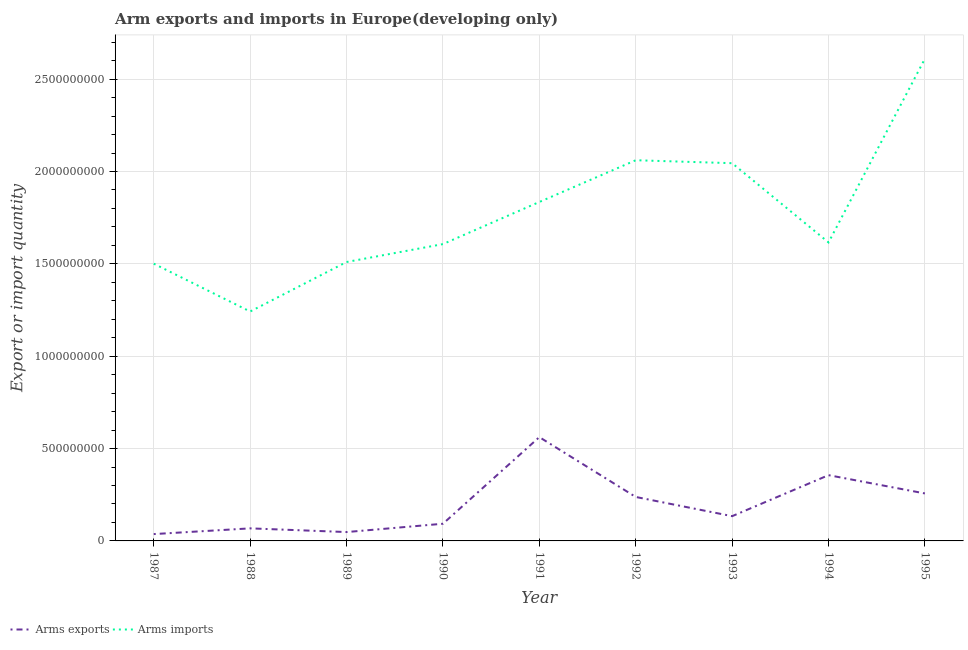Does the line corresponding to arms imports intersect with the line corresponding to arms exports?
Offer a terse response. No. What is the arms imports in 1987?
Your answer should be very brief. 1.50e+09. Across all years, what is the maximum arms exports?
Give a very brief answer. 5.62e+08. Across all years, what is the minimum arms exports?
Offer a very short reply. 3.70e+07. In which year was the arms imports maximum?
Offer a very short reply. 1995. What is the total arms imports in the graph?
Your response must be concise. 1.60e+1. What is the difference between the arms imports in 1990 and that in 1992?
Your answer should be very brief. -4.54e+08. What is the difference between the arms imports in 1990 and the arms exports in 1995?
Provide a short and direct response. 1.35e+09. What is the average arms exports per year?
Ensure brevity in your answer.  1.99e+08. In the year 1995, what is the difference between the arms exports and arms imports?
Your answer should be compact. -2.35e+09. In how many years, is the arms exports greater than 2400000000?
Provide a short and direct response. 0. What is the ratio of the arms imports in 1988 to that in 1989?
Offer a very short reply. 0.82. What is the difference between the highest and the second highest arms exports?
Your answer should be compact. 2.06e+08. What is the difference between the highest and the lowest arms exports?
Offer a terse response. 5.25e+08. Is the arms imports strictly greater than the arms exports over the years?
Provide a succinct answer. Yes. How many lines are there?
Make the answer very short. 2. What is the difference between two consecutive major ticks on the Y-axis?
Make the answer very short. 5.00e+08. Are the values on the major ticks of Y-axis written in scientific E-notation?
Your answer should be very brief. No. Does the graph contain any zero values?
Your answer should be very brief. No. Where does the legend appear in the graph?
Offer a terse response. Bottom left. How many legend labels are there?
Provide a succinct answer. 2. What is the title of the graph?
Offer a terse response. Arm exports and imports in Europe(developing only). Does "DAC donors" appear as one of the legend labels in the graph?
Offer a very short reply. No. What is the label or title of the Y-axis?
Ensure brevity in your answer.  Export or import quantity. What is the Export or import quantity in Arms exports in 1987?
Provide a short and direct response. 3.70e+07. What is the Export or import quantity in Arms imports in 1987?
Your answer should be very brief. 1.50e+09. What is the Export or import quantity in Arms exports in 1988?
Your answer should be compact. 6.80e+07. What is the Export or import quantity in Arms imports in 1988?
Your answer should be very brief. 1.24e+09. What is the Export or import quantity of Arms exports in 1989?
Offer a very short reply. 4.80e+07. What is the Export or import quantity of Arms imports in 1989?
Offer a terse response. 1.51e+09. What is the Export or import quantity in Arms exports in 1990?
Ensure brevity in your answer.  9.30e+07. What is the Export or import quantity of Arms imports in 1990?
Provide a short and direct response. 1.61e+09. What is the Export or import quantity of Arms exports in 1991?
Provide a succinct answer. 5.62e+08. What is the Export or import quantity in Arms imports in 1991?
Provide a short and direct response. 1.84e+09. What is the Export or import quantity in Arms exports in 1992?
Your answer should be compact. 2.38e+08. What is the Export or import quantity in Arms imports in 1992?
Ensure brevity in your answer.  2.06e+09. What is the Export or import quantity in Arms exports in 1993?
Provide a succinct answer. 1.34e+08. What is the Export or import quantity of Arms imports in 1993?
Offer a terse response. 2.04e+09. What is the Export or import quantity in Arms exports in 1994?
Ensure brevity in your answer.  3.56e+08. What is the Export or import quantity in Arms imports in 1994?
Give a very brief answer. 1.62e+09. What is the Export or import quantity of Arms exports in 1995?
Ensure brevity in your answer.  2.57e+08. What is the Export or import quantity in Arms imports in 1995?
Your response must be concise. 2.61e+09. Across all years, what is the maximum Export or import quantity of Arms exports?
Keep it short and to the point. 5.62e+08. Across all years, what is the maximum Export or import quantity of Arms imports?
Your response must be concise. 2.61e+09. Across all years, what is the minimum Export or import quantity of Arms exports?
Ensure brevity in your answer.  3.70e+07. Across all years, what is the minimum Export or import quantity of Arms imports?
Offer a very short reply. 1.24e+09. What is the total Export or import quantity of Arms exports in the graph?
Provide a short and direct response. 1.79e+09. What is the total Export or import quantity in Arms imports in the graph?
Keep it short and to the point. 1.60e+1. What is the difference between the Export or import quantity in Arms exports in 1987 and that in 1988?
Give a very brief answer. -3.10e+07. What is the difference between the Export or import quantity of Arms imports in 1987 and that in 1988?
Provide a short and direct response. 2.59e+08. What is the difference between the Export or import quantity in Arms exports in 1987 and that in 1989?
Provide a short and direct response. -1.10e+07. What is the difference between the Export or import quantity in Arms imports in 1987 and that in 1989?
Your response must be concise. -9.00e+06. What is the difference between the Export or import quantity in Arms exports in 1987 and that in 1990?
Keep it short and to the point. -5.60e+07. What is the difference between the Export or import quantity in Arms imports in 1987 and that in 1990?
Your answer should be compact. -1.06e+08. What is the difference between the Export or import quantity of Arms exports in 1987 and that in 1991?
Your answer should be very brief. -5.25e+08. What is the difference between the Export or import quantity of Arms imports in 1987 and that in 1991?
Your answer should be very brief. -3.34e+08. What is the difference between the Export or import quantity in Arms exports in 1987 and that in 1992?
Your response must be concise. -2.01e+08. What is the difference between the Export or import quantity of Arms imports in 1987 and that in 1992?
Provide a short and direct response. -5.60e+08. What is the difference between the Export or import quantity of Arms exports in 1987 and that in 1993?
Offer a very short reply. -9.70e+07. What is the difference between the Export or import quantity in Arms imports in 1987 and that in 1993?
Offer a very short reply. -5.44e+08. What is the difference between the Export or import quantity in Arms exports in 1987 and that in 1994?
Provide a short and direct response. -3.19e+08. What is the difference between the Export or import quantity of Arms imports in 1987 and that in 1994?
Make the answer very short. -1.15e+08. What is the difference between the Export or import quantity of Arms exports in 1987 and that in 1995?
Make the answer very short. -2.20e+08. What is the difference between the Export or import quantity in Arms imports in 1987 and that in 1995?
Your response must be concise. -1.11e+09. What is the difference between the Export or import quantity in Arms exports in 1988 and that in 1989?
Offer a terse response. 2.00e+07. What is the difference between the Export or import quantity of Arms imports in 1988 and that in 1989?
Provide a succinct answer. -2.68e+08. What is the difference between the Export or import quantity of Arms exports in 1988 and that in 1990?
Your answer should be very brief. -2.50e+07. What is the difference between the Export or import quantity in Arms imports in 1988 and that in 1990?
Give a very brief answer. -3.65e+08. What is the difference between the Export or import quantity in Arms exports in 1988 and that in 1991?
Offer a very short reply. -4.94e+08. What is the difference between the Export or import quantity of Arms imports in 1988 and that in 1991?
Offer a terse response. -5.93e+08. What is the difference between the Export or import quantity of Arms exports in 1988 and that in 1992?
Give a very brief answer. -1.70e+08. What is the difference between the Export or import quantity of Arms imports in 1988 and that in 1992?
Make the answer very short. -8.19e+08. What is the difference between the Export or import quantity in Arms exports in 1988 and that in 1993?
Keep it short and to the point. -6.60e+07. What is the difference between the Export or import quantity in Arms imports in 1988 and that in 1993?
Offer a very short reply. -8.03e+08. What is the difference between the Export or import quantity of Arms exports in 1988 and that in 1994?
Provide a short and direct response. -2.88e+08. What is the difference between the Export or import quantity in Arms imports in 1988 and that in 1994?
Your answer should be very brief. -3.74e+08. What is the difference between the Export or import quantity of Arms exports in 1988 and that in 1995?
Your response must be concise. -1.89e+08. What is the difference between the Export or import quantity of Arms imports in 1988 and that in 1995?
Your answer should be compact. -1.37e+09. What is the difference between the Export or import quantity of Arms exports in 1989 and that in 1990?
Provide a succinct answer. -4.50e+07. What is the difference between the Export or import quantity of Arms imports in 1989 and that in 1990?
Your answer should be compact. -9.70e+07. What is the difference between the Export or import quantity in Arms exports in 1989 and that in 1991?
Provide a short and direct response. -5.14e+08. What is the difference between the Export or import quantity in Arms imports in 1989 and that in 1991?
Provide a short and direct response. -3.25e+08. What is the difference between the Export or import quantity in Arms exports in 1989 and that in 1992?
Make the answer very short. -1.90e+08. What is the difference between the Export or import quantity in Arms imports in 1989 and that in 1992?
Give a very brief answer. -5.51e+08. What is the difference between the Export or import quantity of Arms exports in 1989 and that in 1993?
Ensure brevity in your answer.  -8.60e+07. What is the difference between the Export or import quantity of Arms imports in 1989 and that in 1993?
Your answer should be very brief. -5.35e+08. What is the difference between the Export or import quantity in Arms exports in 1989 and that in 1994?
Your answer should be compact. -3.08e+08. What is the difference between the Export or import quantity in Arms imports in 1989 and that in 1994?
Make the answer very short. -1.06e+08. What is the difference between the Export or import quantity of Arms exports in 1989 and that in 1995?
Ensure brevity in your answer.  -2.09e+08. What is the difference between the Export or import quantity of Arms imports in 1989 and that in 1995?
Offer a terse response. -1.10e+09. What is the difference between the Export or import quantity of Arms exports in 1990 and that in 1991?
Ensure brevity in your answer.  -4.69e+08. What is the difference between the Export or import quantity in Arms imports in 1990 and that in 1991?
Your answer should be compact. -2.28e+08. What is the difference between the Export or import quantity in Arms exports in 1990 and that in 1992?
Keep it short and to the point. -1.45e+08. What is the difference between the Export or import quantity of Arms imports in 1990 and that in 1992?
Keep it short and to the point. -4.54e+08. What is the difference between the Export or import quantity of Arms exports in 1990 and that in 1993?
Your response must be concise. -4.10e+07. What is the difference between the Export or import quantity in Arms imports in 1990 and that in 1993?
Provide a succinct answer. -4.38e+08. What is the difference between the Export or import quantity in Arms exports in 1990 and that in 1994?
Ensure brevity in your answer.  -2.63e+08. What is the difference between the Export or import quantity of Arms imports in 1990 and that in 1994?
Your answer should be compact. -9.00e+06. What is the difference between the Export or import quantity of Arms exports in 1990 and that in 1995?
Your response must be concise. -1.64e+08. What is the difference between the Export or import quantity in Arms imports in 1990 and that in 1995?
Keep it short and to the point. -1.00e+09. What is the difference between the Export or import quantity of Arms exports in 1991 and that in 1992?
Make the answer very short. 3.24e+08. What is the difference between the Export or import quantity of Arms imports in 1991 and that in 1992?
Provide a short and direct response. -2.26e+08. What is the difference between the Export or import quantity of Arms exports in 1991 and that in 1993?
Your answer should be compact. 4.28e+08. What is the difference between the Export or import quantity in Arms imports in 1991 and that in 1993?
Provide a succinct answer. -2.10e+08. What is the difference between the Export or import quantity in Arms exports in 1991 and that in 1994?
Provide a succinct answer. 2.06e+08. What is the difference between the Export or import quantity in Arms imports in 1991 and that in 1994?
Your answer should be compact. 2.19e+08. What is the difference between the Export or import quantity of Arms exports in 1991 and that in 1995?
Offer a very short reply. 3.05e+08. What is the difference between the Export or import quantity of Arms imports in 1991 and that in 1995?
Give a very brief answer. -7.76e+08. What is the difference between the Export or import quantity of Arms exports in 1992 and that in 1993?
Keep it short and to the point. 1.04e+08. What is the difference between the Export or import quantity in Arms imports in 1992 and that in 1993?
Offer a very short reply. 1.60e+07. What is the difference between the Export or import quantity in Arms exports in 1992 and that in 1994?
Make the answer very short. -1.18e+08. What is the difference between the Export or import quantity in Arms imports in 1992 and that in 1994?
Your response must be concise. 4.45e+08. What is the difference between the Export or import quantity in Arms exports in 1992 and that in 1995?
Make the answer very short. -1.90e+07. What is the difference between the Export or import quantity in Arms imports in 1992 and that in 1995?
Keep it short and to the point. -5.50e+08. What is the difference between the Export or import quantity in Arms exports in 1993 and that in 1994?
Keep it short and to the point. -2.22e+08. What is the difference between the Export or import quantity in Arms imports in 1993 and that in 1994?
Provide a succinct answer. 4.29e+08. What is the difference between the Export or import quantity of Arms exports in 1993 and that in 1995?
Provide a short and direct response. -1.23e+08. What is the difference between the Export or import quantity of Arms imports in 1993 and that in 1995?
Keep it short and to the point. -5.66e+08. What is the difference between the Export or import quantity in Arms exports in 1994 and that in 1995?
Offer a terse response. 9.90e+07. What is the difference between the Export or import quantity of Arms imports in 1994 and that in 1995?
Ensure brevity in your answer.  -9.95e+08. What is the difference between the Export or import quantity in Arms exports in 1987 and the Export or import quantity in Arms imports in 1988?
Provide a short and direct response. -1.20e+09. What is the difference between the Export or import quantity in Arms exports in 1987 and the Export or import quantity in Arms imports in 1989?
Give a very brief answer. -1.47e+09. What is the difference between the Export or import quantity in Arms exports in 1987 and the Export or import quantity in Arms imports in 1990?
Give a very brief answer. -1.57e+09. What is the difference between the Export or import quantity of Arms exports in 1987 and the Export or import quantity of Arms imports in 1991?
Give a very brief answer. -1.80e+09. What is the difference between the Export or import quantity in Arms exports in 1987 and the Export or import quantity in Arms imports in 1992?
Provide a succinct answer. -2.02e+09. What is the difference between the Export or import quantity in Arms exports in 1987 and the Export or import quantity in Arms imports in 1993?
Keep it short and to the point. -2.01e+09. What is the difference between the Export or import quantity in Arms exports in 1987 and the Export or import quantity in Arms imports in 1994?
Provide a short and direct response. -1.58e+09. What is the difference between the Export or import quantity in Arms exports in 1987 and the Export or import quantity in Arms imports in 1995?
Keep it short and to the point. -2.57e+09. What is the difference between the Export or import quantity in Arms exports in 1988 and the Export or import quantity in Arms imports in 1989?
Your answer should be compact. -1.44e+09. What is the difference between the Export or import quantity of Arms exports in 1988 and the Export or import quantity of Arms imports in 1990?
Keep it short and to the point. -1.54e+09. What is the difference between the Export or import quantity of Arms exports in 1988 and the Export or import quantity of Arms imports in 1991?
Give a very brief answer. -1.77e+09. What is the difference between the Export or import quantity in Arms exports in 1988 and the Export or import quantity in Arms imports in 1992?
Your response must be concise. -1.99e+09. What is the difference between the Export or import quantity in Arms exports in 1988 and the Export or import quantity in Arms imports in 1993?
Offer a very short reply. -1.98e+09. What is the difference between the Export or import quantity in Arms exports in 1988 and the Export or import quantity in Arms imports in 1994?
Offer a terse response. -1.55e+09. What is the difference between the Export or import quantity of Arms exports in 1988 and the Export or import quantity of Arms imports in 1995?
Ensure brevity in your answer.  -2.54e+09. What is the difference between the Export or import quantity in Arms exports in 1989 and the Export or import quantity in Arms imports in 1990?
Provide a succinct answer. -1.56e+09. What is the difference between the Export or import quantity of Arms exports in 1989 and the Export or import quantity of Arms imports in 1991?
Make the answer very short. -1.79e+09. What is the difference between the Export or import quantity of Arms exports in 1989 and the Export or import quantity of Arms imports in 1992?
Your answer should be compact. -2.01e+09. What is the difference between the Export or import quantity of Arms exports in 1989 and the Export or import quantity of Arms imports in 1993?
Make the answer very short. -2.00e+09. What is the difference between the Export or import quantity of Arms exports in 1989 and the Export or import quantity of Arms imports in 1994?
Your answer should be very brief. -1.57e+09. What is the difference between the Export or import quantity of Arms exports in 1989 and the Export or import quantity of Arms imports in 1995?
Make the answer very short. -2.56e+09. What is the difference between the Export or import quantity in Arms exports in 1990 and the Export or import quantity in Arms imports in 1991?
Keep it short and to the point. -1.74e+09. What is the difference between the Export or import quantity of Arms exports in 1990 and the Export or import quantity of Arms imports in 1992?
Offer a very short reply. -1.97e+09. What is the difference between the Export or import quantity in Arms exports in 1990 and the Export or import quantity in Arms imports in 1993?
Offer a terse response. -1.95e+09. What is the difference between the Export or import quantity in Arms exports in 1990 and the Export or import quantity in Arms imports in 1994?
Offer a very short reply. -1.52e+09. What is the difference between the Export or import quantity in Arms exports in 1990 and the Export or import quantity in Arms imports in 1995?
Keep it short and to the point. -2.52e+09. What is the difference between the Export or import quantity of Arms exports in 1991 and the Export or import quantity of Arms imports in 1992?
Your response must be concise. -1.50e+09. What is the difference between the Export or import quantity of Arms exports in 1991 and the Export or import quantity of Arms imports in 1993?
Your answer should be very brief. -1.48e+09. What is the difference between the Export or import quantity in Arms exports in 1991 and the Export or import quantity in Arms imports in 1994?
Ensure brevity in your answer.  -1.05e+09. What is the difference between the Export or import quantity in Arms exports in 1991 and the Export or import quantity in Arms imports in 1995?
Give a very brief answer. -2.05e+09. What is the difference between the Export or import quantity in Arms exports in 1992 and the Export or import quantity in Arms imports in 1993?
Keep it short and to the point. -1.81e+09. What is the difference between the Export or import quantity in Arms exports in 1992 and the Export or import quantity in Arms imports in 1994?
Offer a terse response. -1.38e+09. What is the difference between the Export or import quantity of Arms exports in 1992 and the Export or import quantity of Arms imports in 1995?
Provide a short and direct response. -2.37e+09. What is the difference between the Export or import quantity in Arms exports in 1993 and the Export or import quantity in Arms imports in 1994?
Make the answer very short. -1.48e+09. What is the difference between the Export or import quantity in Arms exports in 1993 and the Export or import quantity in Arms imports in 1995?
Your answer should be very brief. -2.48e+09. What is the difference between the Export or import quantity of Arms exports in 1994 and the Export or import quantity of Arms imports in 1995?
Give a very brief answer. -2.26e+09. What is the average Export or import quantity in Arms exports per year?
Your answer should be compact. 1.99e+08. What is the average Export or import quantity in Arms imports per year?
Your answer should be very brief. 1.78e+09. In the year 1987, what is the difference between the Export or import quantity of Arms exports and Export or import quantity of Arms imports?
Offer a very short reply. -1.46e+09. In the year 1988, what is the difference between the Export or import quantity of Arms exports and Export or import quantity of Arms imports?
Your answer should be compact. -1.17e+09. In the year 1989, what is the difference between the Export or import quantity in Arms exports and Export or import quantity in Arms imports?
Your response must be concise. -1.46e+09. In the year 1990, what is the difference between the Export or import quantity of Arms exports and Export or import quantity of Arms imports?
Your response must be concise. -1.51e+09. In the year 1991, what is the difference between the Export or import quantity of Arms exports and Export or import quantity of Arms imports?
Ensure brevity in your answer.  -1.27e+09. In the year 1992, what is the difference between the Export or import quantity of Arms exports and Export or import quantity of Arms imports?
Your response must be concise. -1.82e+09. In the year 1993, what is the difference between the Export or import quantity of Arms exports and Export or import quantity of Arms imports?
Make the answer very short. -1.91e+09. In the year 1994, what is the difference between the Export or import quantity in Arms exports and Export or import quantity in Arms imports?
Provide a short and direct response. -1.26e+09. In the year 1995, what is the difference between the Export or import quantity in Arms exports and Export or import quantity in Arms imports?
Give a very brief answer. -2.35e+09. What is the ratio of the Export or import quantity in Arms exports in 1987 to that in 1988?
Keep it short and to the point. 0.54. What is the ratio of the Export or import quantity in Arms imports in 1987 to that in 1988?
Provide a short and direct response. 1.21. What is the ratio of the Export or import quantity in Arms exports in 1987 to that in 1989?
Your answer should be very brief. 0.77. What is the ratio of the Export or import quantity in Arms imports in 1987 to that in 1989?
Keep it short and to the point. 0.99. What is the ratio of the Export or import quantity of Arms exports in 1987 to that in 1990?
Provide a short and direct response. 0.4. What is the ratio of the Export or import quantity in Arms imports in 1987 to that in 1990?
Provide a succinct answer. 0.93. What is the ratio of the Export or import quantity of Arms exports in 1987 to that in 1991?
Ensure brevity in your answer.  0.07. What is the ratio of the Export or import quantity in Arms imports in 1987 to that in 1991?
Your response must be concise. 0.82. What is the ratio of the Export or import quantity of Arms exports in 1987 to that in 1992?
Provide a short and direct response. 0.16. What is the ratio of the Export or import quantity in Arms imports in 1987 to that in 1992?
Offer a very short reply. 0.73. What is the ratio of the Export or import quantity in Arms exports in 1987 to that in 1993?
Give a very brief answer. 0.28. What is the ratio of the Export or import quantity in Arms imports in 1987 to that in 1993?
Offer a very short reply. 0.73. What is the ratio of the Export or import quantity of Arms exports in 1987 to that in 1994?
Your response must be concise. 0.1. What is the ratio of the Export or import quantity of Arms imports in 1987 to that in 1994?
Keep it short and to the point. 0.93. What is the ratio of the Export or import quantity in Arms exports in 1987 to that in 1995?
Make the answer very short. 0.14. What is the ratio of the Export or import quantity of Arms imports in 1987 to that in 1995?
Provide a short and direct response. 0.57. What is the ratio of the Export or import quantity of Arms exports in 1988 to that in 1989?
Provide a succinct answer. 1.42. What is the ratio of the Export or import quantity of Arms imports in 1988 to that in 1989?
Give a very brief answer. 0.82. What is the ratio of the Export or import quantity of Arms exports in 1988 to that in 1990?
Your response must be concise. 0.73. What is the ratio of the Export or import quantity of Arms imports in 1988 to that in 1990?
Provide a short and direct response. 0.77. What is the ratio of the Export or import quantity in Arms exports in 1988 to that in 1991?
Your answer should be very brief. 0.12. What is the ratio of the Export or import quantity of Arms imports in 1988 to that in 1991?
Make the answer very short. 0.68. What is the ratio of the Export or import quantity in Arms exports in 1988 to that in 1992?
Make the answer very short. 0.29. What is the ratio of the Export or import quantity of Arms imports in 1988 to that in 1992?
Offer a very short reply. 0.6. What is the ratio of the Export or import quantity of Arms exports in 1988 to that in 1993?
Offer a very short reply. 0.51. What is the ratio of the Export or import quantity of Arms imports in 1988 to that in 1993?
Your answer should be compact. 0.61. What is the ratio of the Export or import quantity of Arms exports in 1988 to that in 1994?
Your answer should be very brief. 0.19. What is the ratio of the Export or import quantity in Arms imports in 1988 to that in 1994?
Ensure brevity in your answer.  0.77. What is the ratio of the Export or import quantity of Arms exports in 1988 to that in 1995?
Make the answer very short. 0.26. What is the ratio of the Export or import quantity of Arms imports in 1988 to that in 1995?
Give a very brief answer. 0.48. What is the ratio of the Export or import quantity in Arms exports in 1989 to that in 1990?
Offer a very short reply. 0.52. What is the ratio of the Export or import quantity of Arms imports in 1989 to that in 1990?
Offer a terse response. 0.94. What is the ratio of the Export or import quantity in Arms exports in 1989 to that in 1991?
Provide a short and direct response. 0.09. What is the ratio of the Export or import quantity in Arms imports in 1989 to that in 1991?
Offer a very short reply. 0.82. What is the ratio of the Export or import quantity in Arms exports in 1989 to that in 1992?
Your answer should be very brief. 0.2. What is the ratio of the Export or import quantity of Arms imports in 1989 to that in 1992?
Keep it short and to the point. 0.73. What is the ratio of the Export or import quantity in Arms exports in 1989 to that in 1993?
Provide a succinct answer. 0.36. What is the ratio of the Export or import quantity in Arms imports in 1989 to that in 1993?
Offer a very short reply. 0.74. What is the ratio of the Export or import quantity of Arms exports in 1989 to that in 1994?
Provide a succinct answer. 0.13. What is the ratio of the Export or import quantity of Arms imports in 1989 to that in 1994?
Ensure brevity in your answer.  0.93. What is the ratio of the Export or import quantity in Arms exports in 1989 to that in 1995?
Provide a succinct answer. 0.19. What is the ratio of the Export or import quantity in Arms imports in 1989 to that in 1995?
Offer a very short reply. 0.58. What is the ratio of the Export or import quantity of Arms exports in 1990 to that in 1991?
Provide a short and direct response. 0.17. What is the ratio of the Export or import quantity in Arms imports in 1990 to that in 1991?
Make the answer very short. 0.88. What is the ratio of the Export or import quantity in Arms exports in 1990 to that in 1992?
Your response must be concise. 0.39. What is the ratio of the Export or import quantity of Arms imports in 1990 to that in 1992?
Your answer should be very brief. 0.78. What is the ratio of the Export or import quantity of Arms exports in 1990 to that in 1993?
Keep it short and to the point. 0.69. What is the ratio of the Export or import quantity of Arms imports in 1990 to that in 1993?
Provide a short and direct response. 0.79. What is the ratio of the Export or import quantity in Arms exports in 1990 to that in 1994?
Ensure brevity in your answer.  0.26. What is the ratio of the Export or import quantity in Arms exports in 1990 to that in 1995?
Ensure brevity in your answer.  0.36. What is the ratio of the Export or import quantity in Arms imports in 1990 to that in 1995?
Provide a succinct answer. 0.62. What is the ratio of the Export or import quantity in Arms exports in 1991 to that in 1992?
Give a very brief answer. 2.36. What is the ratio of the Export or import quantity of Arms imports in 1991 to that in 1992?
Ensure brevity in your answer.  0.89. What is the ratio of the Export or import quantity of Arms exports in 1991 to that in 1993?
Offer a terse response. 4.19. What is the ratio of the Export or import quantity in Arms imports in 1991 to that in 1993?
Provide a succinct answer. 0.9. What is the ratio of the Export or import quantity of Arms exports in 1991 to that in 1994?
Provide a succinct answer. 1.58. What is the ratio of the Export or import quantity of Arms imports in 1991 to that in 1994?
Your answer should be compact. 1.14. What is the ratio of the Export or import quantity in Arms exports in 1991 to that in 1995?
Make the answer very short. 2.19. What is the ratio of the Export or import quantity in Arms imports in 1991 to that in 1995?
Give a very brief answer. 0.7. What is the ratio of the Export or import quantity of Arms exports in 1992 to that in 1993?
Offer a very short reply. 1.78. What is the ratio of the Export or import quantity in Arms imports in 1992 to that in 1993?
Provide a short and direct response. 1.01. What is the ratio of the Export or import quantity in Arms exports in 1992 to that in 1994?
Offer a terse response. 0.67. What is the ratio of the Export or import quantity in Arms imports in 1992 to that in 1994?
Your answer should be very brief. 1.28. What is the ratio of the Export or import quantity of Arms exports in 1992 to that in 1995?
Your answer should be very brief. 0.93. What is the ratio of the Export or import quantity of Arms imports in 1992 to that in 1995?
Ensure brevity in your answer.  0.79. What is the ratio of the Export or import quantity of Arms exports in 1993 to that in 1994?
Your answer should be compact. 0.38. What is the ratio of the Export or import quantity of Arms imports in 1993 to that in 1994?
Your response must be concise. 1.27. What is the ratio of the Export or import quantity in Arms exports in 1993 to that in 1995?
Your answer should be compact. 0.52. What is the ratio of the Export or import quantity of Arms imports in 1993 to that in 1995?
Your response must be concise. 0.78. What is the ratio of the Export or import quantity in Arms exports in 1994 to that in 1995?
Give a very brief answer. 1.39. What is the ratio of the Export or import quantity in Arms imports in 1994 to that in 1995?
Provide a succinct answer. 0.62. What is the difference between the highest and the second highest Export or import quantity of Arms exports?
Ensure brevity in your answer.  2.06e+08. What is the difference between the highest and the second highest Export or import quantity in Arms imports?
Give a very brief answer. 5.50e+08. What is the difference between the highest and the lowest Export or import quantity of Arms exports?
Provide a succinct answer. 5.25e+08. What is the difference between the highest and the lowest Export or import quantity of Arms imports?
Ensure brevity in your answer.  1.37e+09. 